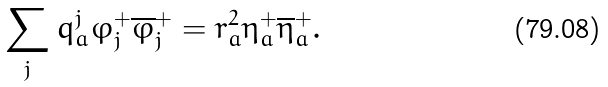Convert formula to latex. <formula><loc_0><loc_0><loc_500><loc_500>\sum _ { j } q ^ { j } _ { a } \varphi _ { j } ^ { + } \overline { \varphi } _ { j } ^ { + } = r ^ { 2 } _ { a } \eta _ { a } ^ { + } \overline { \eta } ^ { + } _ { a } .</formula> 